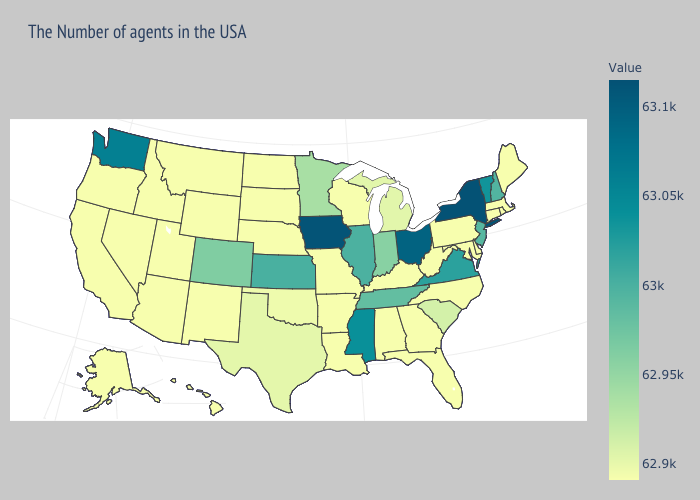Does California have the lowest value in the USA?
Keep it brief. Yes. Among the states that border Georgia , does Florida have the highest value?
Short answer required. No. Among the states that border Kansas , which have the highest value?
Write a very short answer. Colorado. Which states have the highest value in the USA?
Concise answer only. New York. Which states have the lowest value in the Northeast?
Write a very short answer. Maine, Massachusetts, Rhode Island, Connecticut, Pennsylvania. 